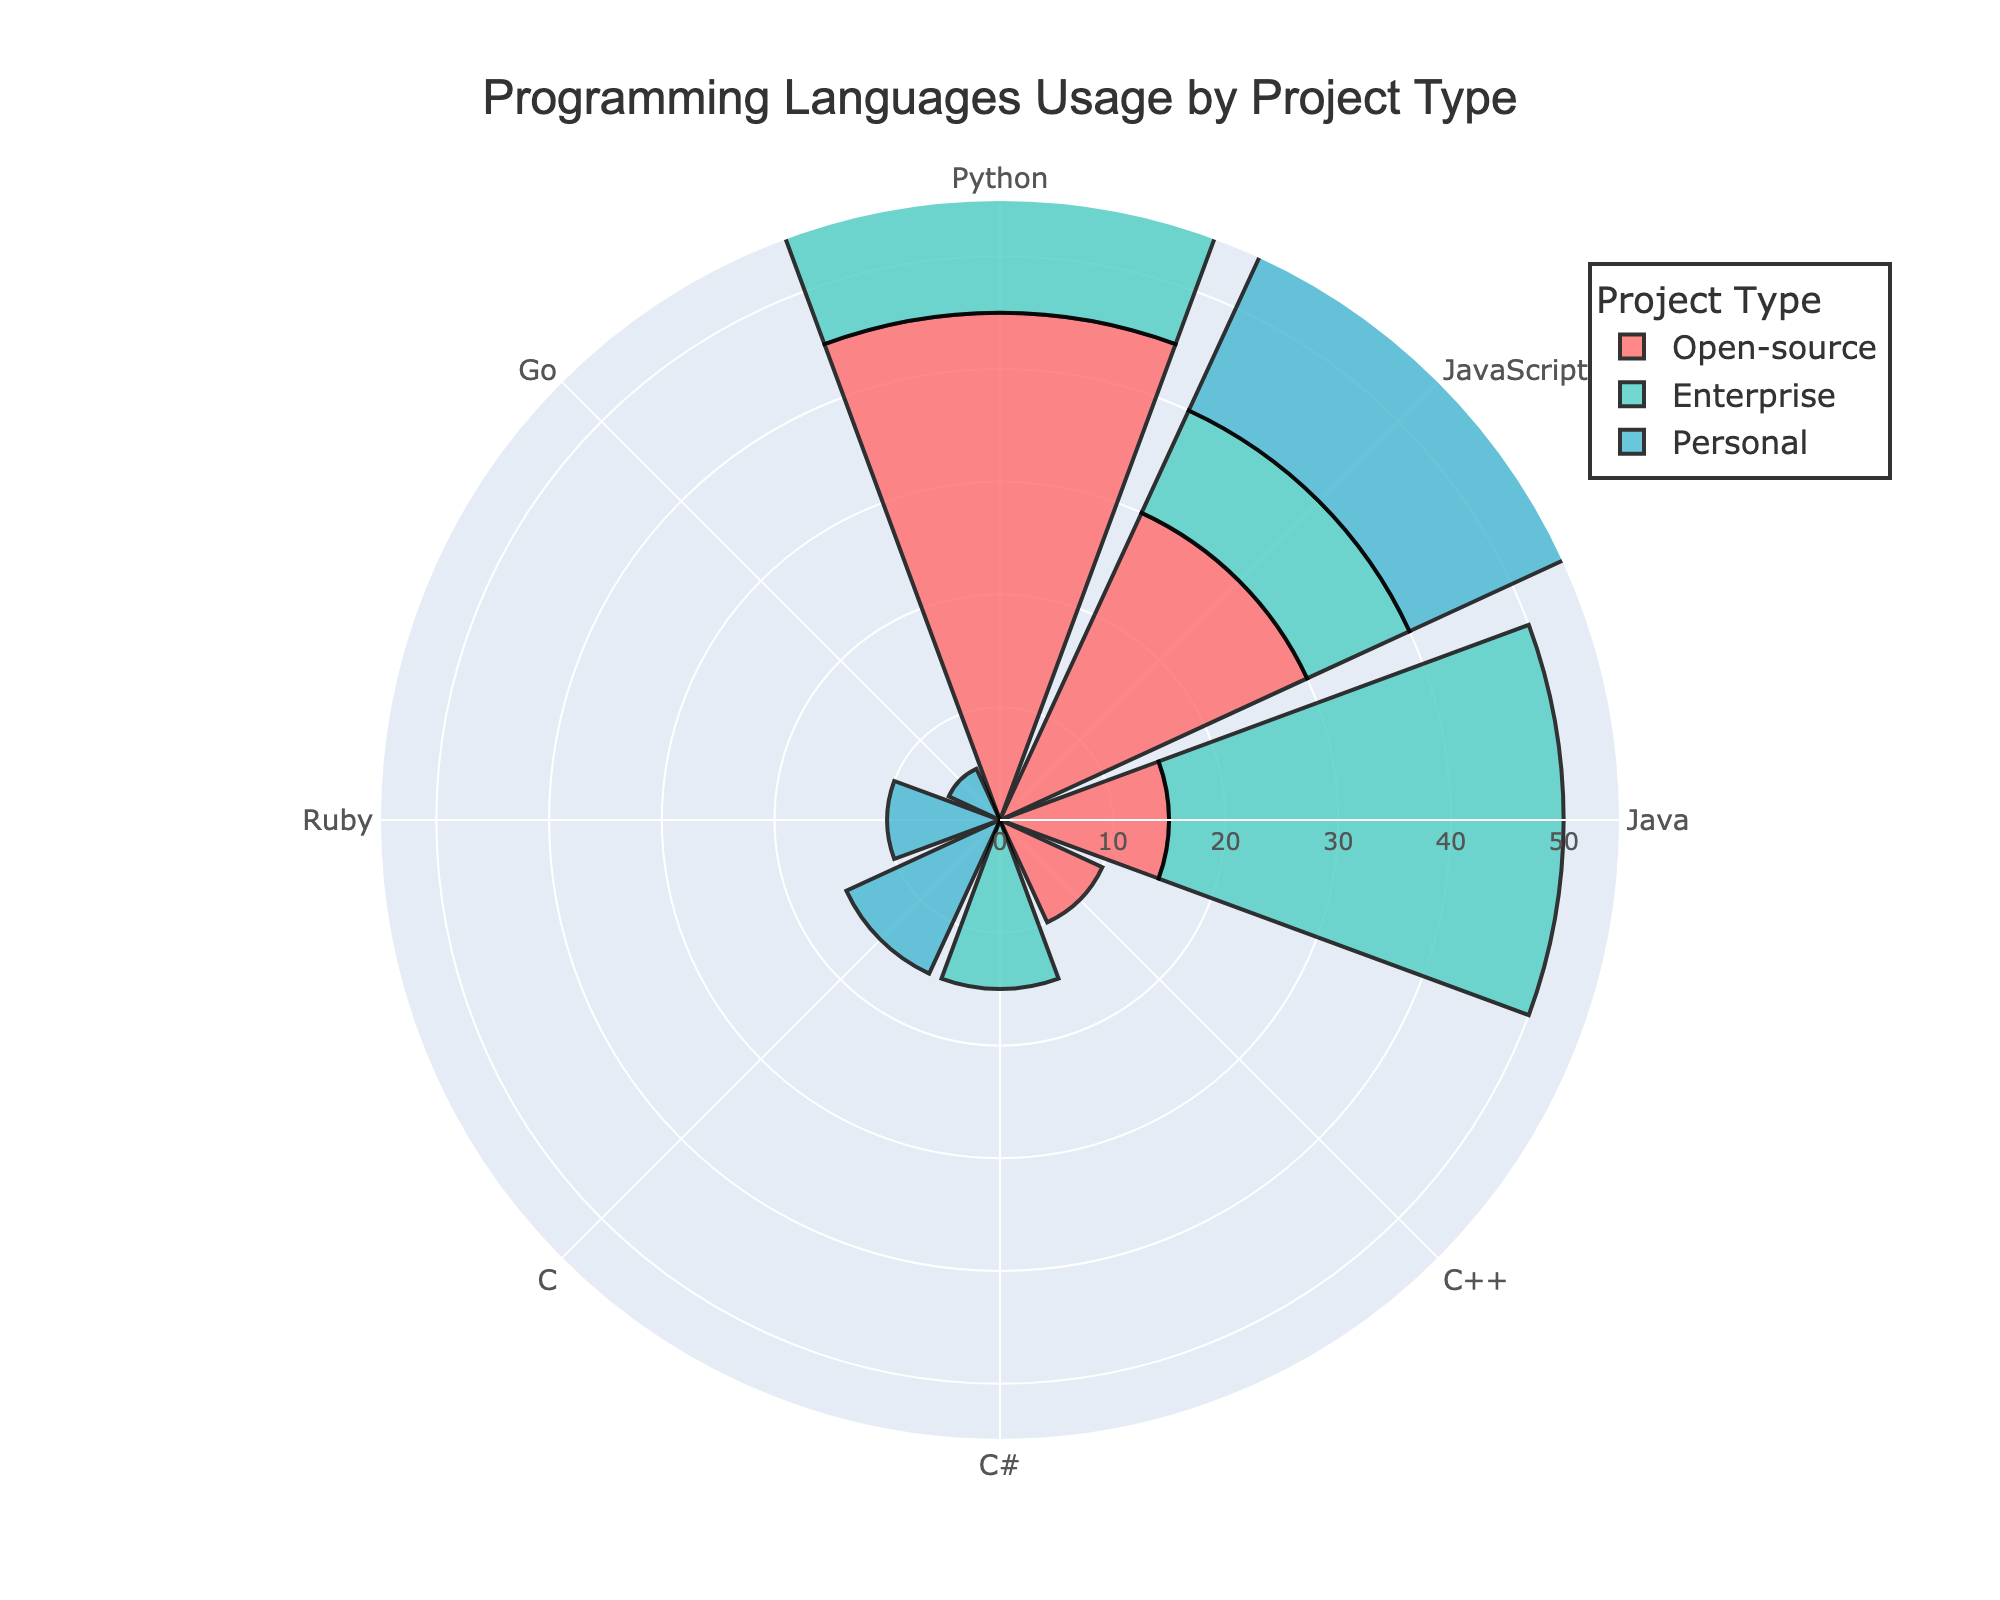What is the title of the plot? The title is displayed at the top of the plot. It provides a summary of the visual content represented in the plot. By reading the text, we see that the title is "Programming Languages Usage by Project Type".
Answer: Programming Languages Usage by Project Type Which project type uses Python the most? We need to look at the bars associated with Python in each of the three project types. The lengths of the bars in the personal projects indicate the highest frequency for Python compared to the open-source and enterprise projects.
Answer: Personal How many data points are there in the Enterprise project type? By analyzing the bar segments and their labels within the Enterprise section of the plot, we count the distinct programming language labels present.
Answer: 4 Which programming language is the least used in Personal projects? By observing the bars for Personal projects, the shortest bar indicates the least used language. In this case, the bar representing Go is the shortest.
Answer: Go What is the total frequency of Java used across all project types? We sum the frequencies of Java from the Open-source and Enterprise sections to gather the total usage. Python does not appear in Personal. Summing these values (15 from Open-source and 35 from Enterprise) gives the total count.
Answer: 50 Compare the frequency of Python between Open-source and Enterprise projects. Which type has a higher frequency? By looking at the bars for Python in both Open-source (45) and Enterprise (40), we see that the Open-source bar is longer.
Answer: Open-source Which project type has an equal and lowest usage of JavaScript? By examining the bars for JavaScript, the lengths in Open-source and Enterprise are both equal and represent the smallest usage compared to Personal. Both have a frequency of 10 while Personal has 20.
Answer: Enterprise and Open-source What is the difference in frequency of C between Open-source and Personal projects? The Personal projects show a bar for C with a frequency of 15, while Open-source does not show any bar for C. Therefore, the difference is simply 15 - 0 = 15.
Answer: 15 Which project type has the most diverse range of programming languages? To determine diversity, we count the number of different programming languages used in each project type. Personal projects show five different programming languages, the highest number compared to Open-source (4) and Enterprise (4).
Answer: Personal What is the average frequency of C++ in Open-source projects compared to C in Personal projects? Open-source has frequency data for C++ which is 10. Personal projects show a frequency of C as 15. The average of these two values is calculated as (10 + 15) / 2 = 12.5.
Answer: 12.5 